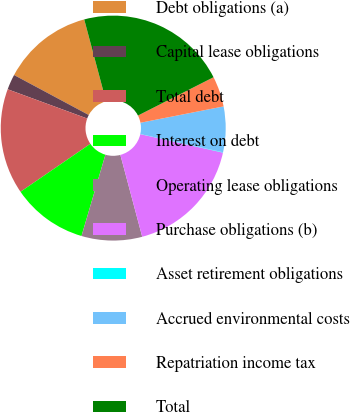Convert chart to OTSL. <chart><loc_0><loc_0><loc_500><loc_500><pie_chart><fcel>Debt obligations (a)<fcel>Capital lease obligations<fcel>Total debt<fcel>Interest on debt<fcel>Operating lease obligations<fcel>Purchase obligations (b)<fcel>Asset retirement obligations<fcel>Accrued environmental costs<fcel>Repatriation income tax<fcel>Total<nl><fcel>13.03%<fcel>2.21%<fcel>15.19%<fcel>10.87%<fcel>8.7%<fcel>17.35%<fcel>0.05%<fcel>6.54%<fcel>4.38%<fcel>21.68%<nl></chart> 